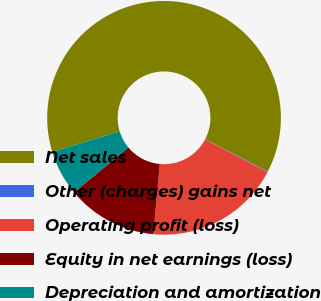Convert chart to OTSL. <chart><loc_0><loc_0><loc_500><loc_500><pie_chart><fcel>Net sales<fcel>Other (charges) gains net<fcel>Operating profit (loss)<fcel>Equity in net earnings (loss)<fcel>Depreciation and amortization<nl><fcel>62.32%<fcel>0.09%<fcel>18.76%<fcel>12.53%<fcel>6.31%<nl></chart> 